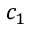<formula> <loc_0><loc_0><loc_500><loc_500>c _ { 1 }</formula> 